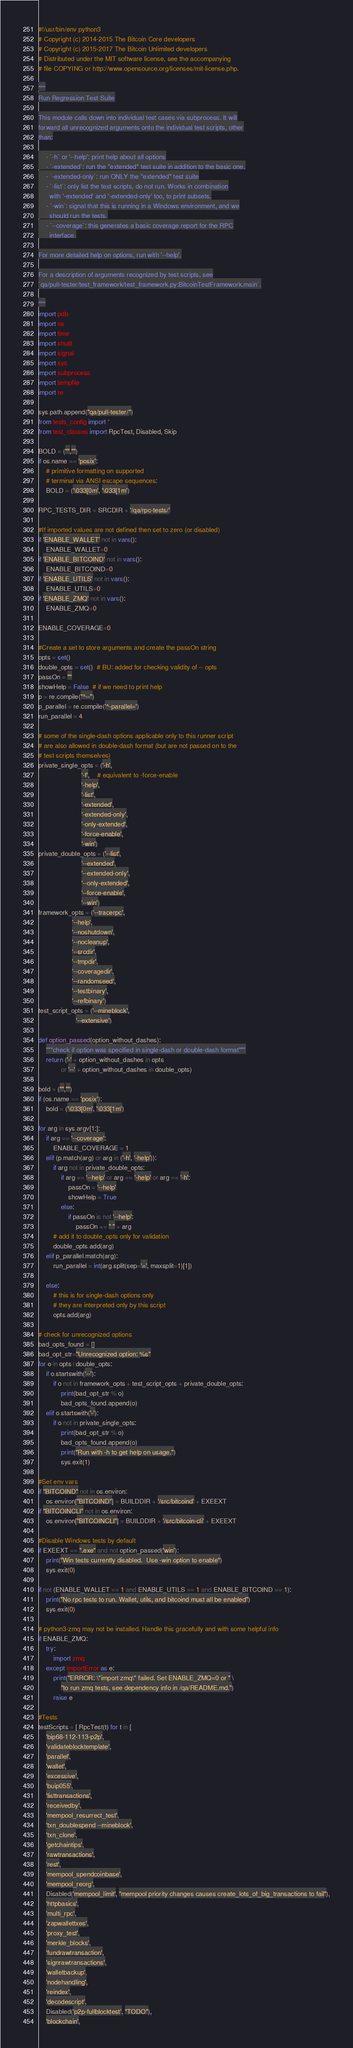<code> <loc_0><loc_0><loc_500><loc_500><_Python_>#!/usr/bin/env python3
# Copyright (c) 2014-2015 The Bitcoin Core developers
# Copyright (c) 2015-2017 The Bitcoin Unlimited developers
# Distributed under the MIT software license, see the accompanying
# file COPYING or http://www.opensource.org/licenses/mit-license.php.

"""
Run Regression Test Suite

This module calls down into individual test cases via subprocess. It will
forward all unrecognized arguments onto the individual test scripts, other
than:

    - `-h` or '--help': print help about all options
    - `-extended`: run the "extended" test suite in addition to the basic one.
    - `-extended-only`: run ONLY the "extended" test suite
    - `-list`: only list the test scripts, do not run. Works in combination
      with '-extended' and '-extended-only' too, to print subsets.
    - `-win`: signal that this is running in a Windows environment, and we
      should run the tests.
    - `--coverage`: this generates a basic coverage report for the RPC
      interface.

For more detailed help on options, run with '--help'.

For a description of arguments recognized by test scripts, see
`qa/pull-tester/test_framework/test_framework.py:BitcoinTestFramework.main`.

"""
import pdb
import os
import time
import shutil
import signal
import sys
import subprocess
import tempfile
import re

sys.path.append("qa/pull-tester/")
from tests_config import *
from test_classes import RpcTest, Disabled, Skip

BOLD = ("","")
if os.name == 'posix':
    # primitive formatting on supported
    # terminal via ANSI escape sequences:
    BOLD = ('\033[0m', '\033[1m')

RPC_TESTS_DIR = SRCDIR + '/qa/rpc-tests/'

#If imported values are not defined then set to zero (or disabled)
if 'ENABLE_WALLET' not in vars():
    ENABLE_WALLET=0
if 'ENABLE_BITCOIND' not in vars():
    ENABLE_BITCOIND=0
if 'ENABLE_UTILS' not in vars():
    ENABLE_UTILS=0
if 'ENABLE_ZMQ' not in vars():
    ENABLE_ZMQ=0

ENABLE_COVERAGE=0

#Create a set to store arguments and create the passOn string
opts = set()
double_opts = set()  # BU: added for checking validity of -- opts
passOn = ""
showHelp = False  # if we need to print help
p = re.compile("^--")
p_parallel = re.compile('^-parallel=')
run_parallel = 4

# some of the single-dash options applicable only to this runner script
# are also allowed in double-dash format (but are not passed on to the
# test scripts themselves)
private_single_opts = ('-h',
                       '-f',    # equivalent to -force-enable
                       '-help',
                       '-list',
                       '-extended',
                       '-extended-only',
                       '-only-extended',
                       '-force-enable',
                       '-win')
private_double_opts = ('--list',
                       '--extended',
                       '--extended-only',
                       '--only-extended',
                       '--force-enable',
                       '--win')
framework_opts = ('--tracerpc',
                  '--help',
                  '--noshutdown',
                  '--nocleanup',
                  '--srcdir',
                  '--tmpdir',
                  '--coveragedir',
                  '--randomseed',
                  '--testbinary',
                  '--refbinary')
test_script_opts = ('--mineblock',
                    '--extensive')

def option_passed(option_without_dashes):
    """check if option was specified in single-dash or double-dash format"""
    return ('-' + option_without_dashes in opts
            or '--' + option_without_dashes in double_opts)

bold = ("","")
if (os.name == 'posix'):
    bold = ('\033[0m', '\033[1m')

for arg in sys.argv[1:]:
    if arg == '--coverage':
        ENABLE_COVERAGE = 1
    elif (p.match(arg) or arg in ('-h', '-help')):
        if arg not in private_double_opts:
            if arg == '--help' or arg == '-help' or arg == '-h':
                passOn = '--help'
                showHelp = True
            else:
                if passOn is not '--help':
                    passOn += " " + arg
        # add it to double_opts only for validation
        double_opts.add(arg)
    elif p_parallel.match(arg):
        run_parallel = int(arg.split(sep='=', maxsplit=1)[1])

    else:
        # this is for single-dash options only
        # they are interpreted only by this script
        opts.add(arg)

# check for unrecognized options
bad_opts_found = []
bad_opt_str="Unrecognized option: %s"
for o in opts | double_opts:
    if o.startswith('--'):
        if o not in framework_opts + test_script_opts + private_double_opts:
            print(bad_opt_str % o)
            bad_opts_found.append(o)
    elif o.startswith('-'):
        if o not in private_single_opts:
            print(bad_opt_str % o)
            bad_opts_found.append(o)
            print("Run with -h to get help on usage.")
            sys.exit(1)

#Set env vars
if "BITCOIND" not in os.environ:
    os.environ["BITCOIND"] = BUILDDIR + '/src/bitcoind' + EXEEXT
if "BITCOINCLI" not in os.environ:
    os.environ["BITCOINCLI"] = BUILDDIR + '/src/bitcoin-cli' + EXEEXT

#Disable Windows tests by default
if EXEEXT == ".exe" and not option_passed('win'):
    print("Win tests currently disabled.  Use -win option to enable")
    sys.exit(0)

if not (ENABLE_WALLET == 1 and ENABLE_UTILS == 1 and ENABLE_BITCOIND == 1):
    print("No rpc tests to run. Wallet, utils, and bitcoind must all be enabled")
    sys.exit(0)

# python3-zmq may not be installed. Handle this gracefully and with some helpful info
if ENABLE_ZMQ:
    try:
        import zmq
    except ImportError as e:
        print("ERROR: \"import zmq\" failed. Set ENABLE_ZMQ=0 or " \
            "to run zmq tests, see dependency info in /qa/README.md.")
        raise e

#Tests
testScripts = [ RpcTest(t) for t in [
    'bip68-112-113-p2p',
    'validateblocktemplate',
    'parallel',
    'wallet',
    'excessive',
    'buip055',
    'listtransactions',
    'receivedby',
    'mempool_resurrect_test',
    'txn_doublespend --mineblock',
    'txn_clone',
    'getchaintips',
    'rawtransactions',
    'rest',
    'mempool_spendcoinbase',
    'mempool_reorg',
    Disabled('mempool_limit', "mempool priority changes causes create_lots_of_big_transactions to fail"),
    'httpbasics',
    'multi_rpc',
    'zapwallettxes',
    'proxy_test',
    'merkle_blocks',
    'fundrawtransaction',
    'signrawtransactions',
    'walletbackup',
    'nodehandling',
    'reindex',
    'decodescript',
    Disabled('p2p-fullblocktest', "TODO"),
    'blockchain',</code> 